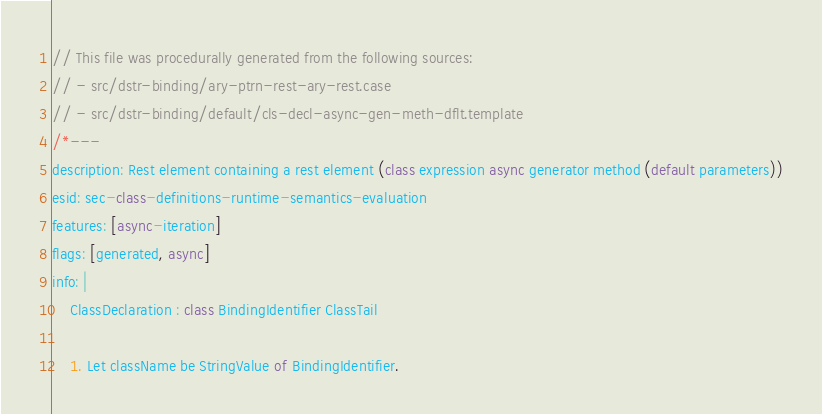Convert code to text. <code><loc_0><loc_0><loc_500><loc_500><_JavaScript_>// This file was procedurally generated from the following sources:
// - src/dstr-binding/ary-ptrn-rest-ary-rest.case
// - src/dstr-binding/default/cls-decl-async-gen-meth-dflt.template
/*---
description: Rest element containing a rest element (class expression async generator method (default parameters))
esid: sec-class-definitions-runtime-semantics-evaluation
features: [async-iteration]
flags: [generated, async]
info: |
    ClassDeclaration : class BindingIdentifier ClassTail

    1. Let className be StringValue of BindingIdentifier.</code> 